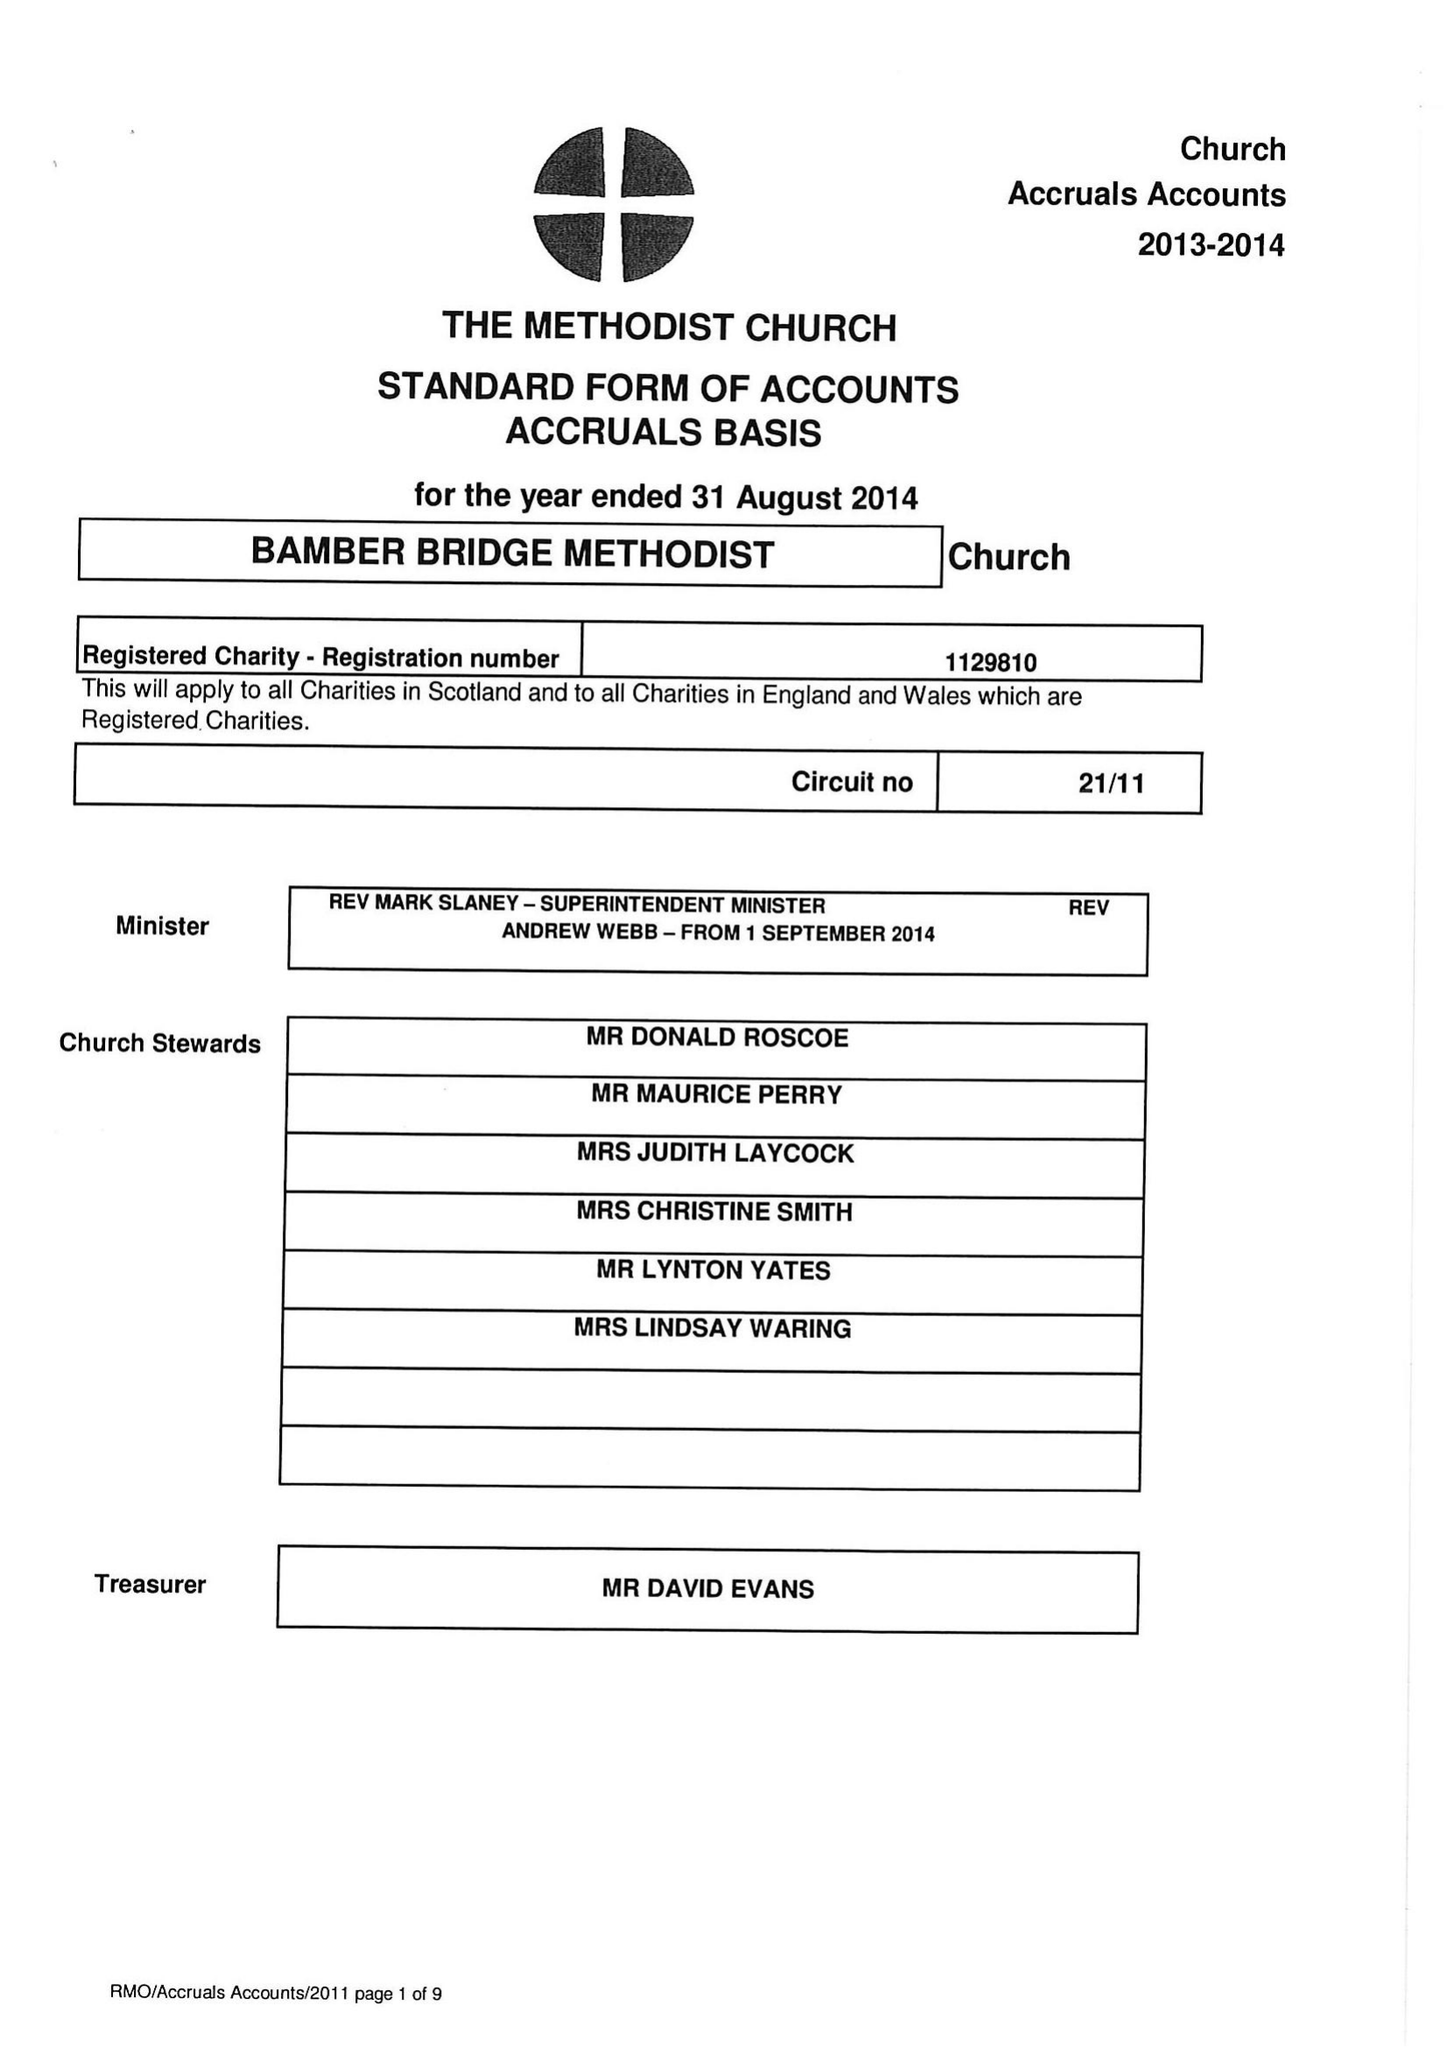What is the value for the charity_number?
Answer the question using a single word or phrase. 1129810 